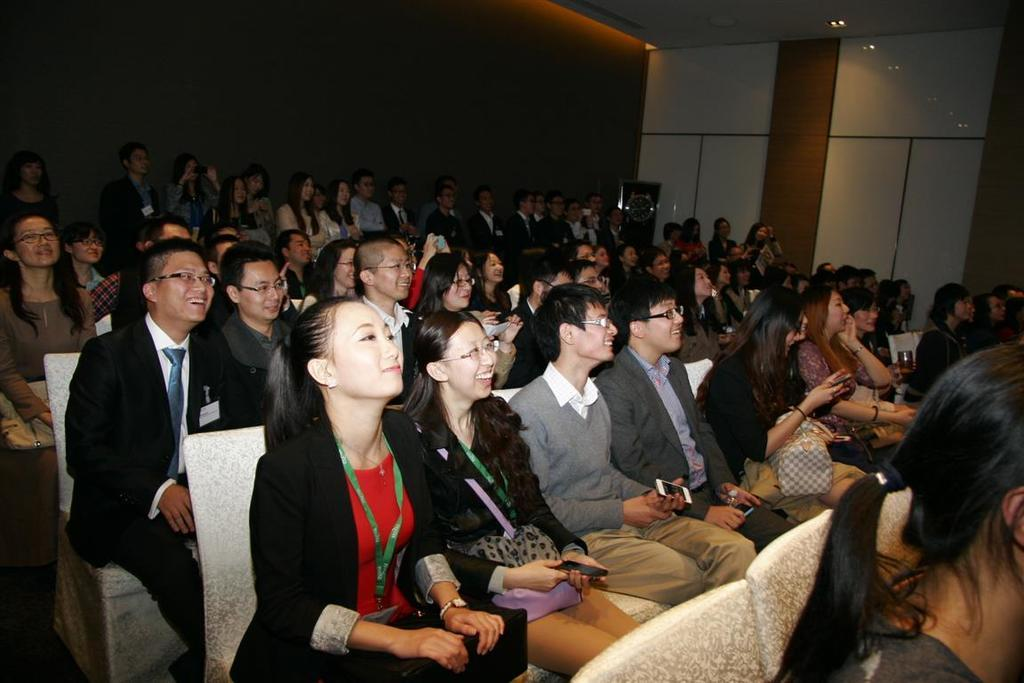What are the people in the image doing? There are many persons sitting on chairs in the image. Can you describe the setting of the image? There are persons visible in the background of the image, and there is a wall in the background. How many pies are being eaten by the persons in the image? There is no mention of pies in the image, so it cannot be determined how many pies are being eaten. 